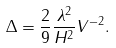Convert formula to latex. <formula><loc_0><loc_0><loc_500><loc_500>\Delta = \frac { 2 } { 9 } \frac { \lambda ^ { 2 } } { H ^ { 2 } } V ^ { - 2 } .</formula> 